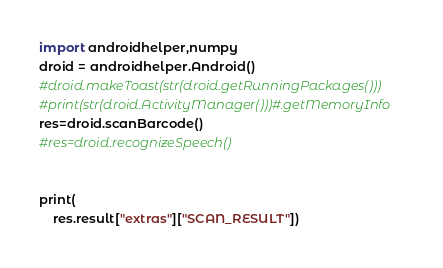Convert code to text. <code><loc_0><loc_0><loc_500><loc_500><_Python_>import androidhelper,numpy
droid = androidhelper.Android()
#droid.makeToast(str(droid.getRunningPackages()))
#print(str(droid.ActivityManager()))#.getMemoryInfo
res=droid.scanBarcode()
#res=droid.recognizeSpeech()


print(
	res.result["extras"]["SCAN_RESULT"])</code> 